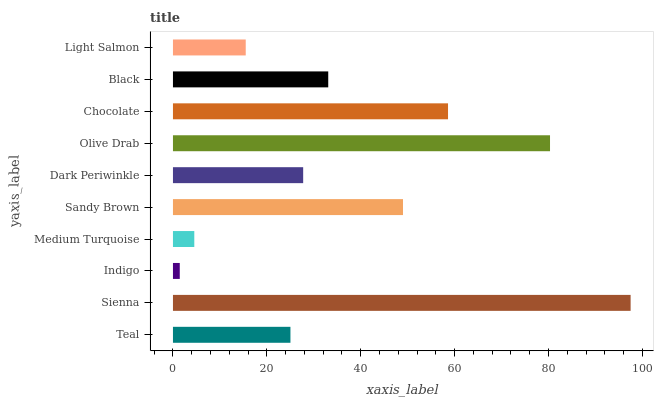Is Indigo the minimum?
Answer yes or no. Yes. Is Sienna the maximum?
Answer yes or no. Yes. Is Sienna the minimum?
Answer yes or no. No. Is Indigo the maximum?
Answer yes or no. No. Is Sienna greater than Indigo?
Answer yes or no. Yes. Is Indigo less than Sienna?
Answer yes or no. Yes. Is Indigo greater than Sienna?
Answer yes or no. No. Is Sienna less than Indigo?
Answer yes or no. No. Is Black the high median?
Answer yes or no. Yes. Is Dark Periwinkle the low median?
Answer yes or no. Yes. Is Sandy Brown the high median?
Answer yes or no. No. Is Chocolate the low median?
Answer yes or no. No. 